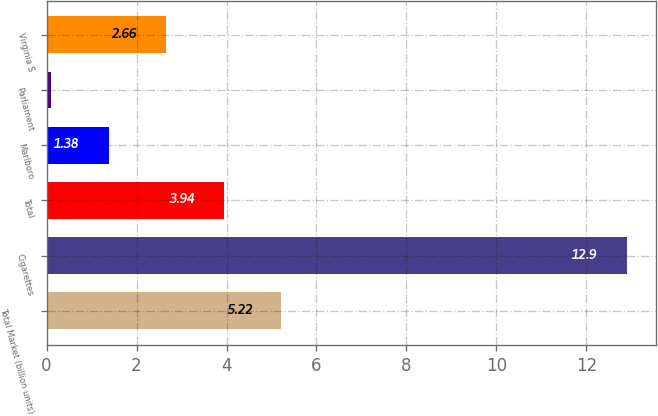Convert chart. <chart><loc_0><loc_0><loc_500><loc_500><bar_chart><fcel>Total Market (billion units)<fcel>Cigarettes<fcel>Total<fcel>Marlboro<fcel>Parliament<fcel>Virginia S<nl><fcel>5.22<fcel>12.9<fcel>3.94<fcel>1.38<fcel>0.1<fcel>2.66<nl></chart> 